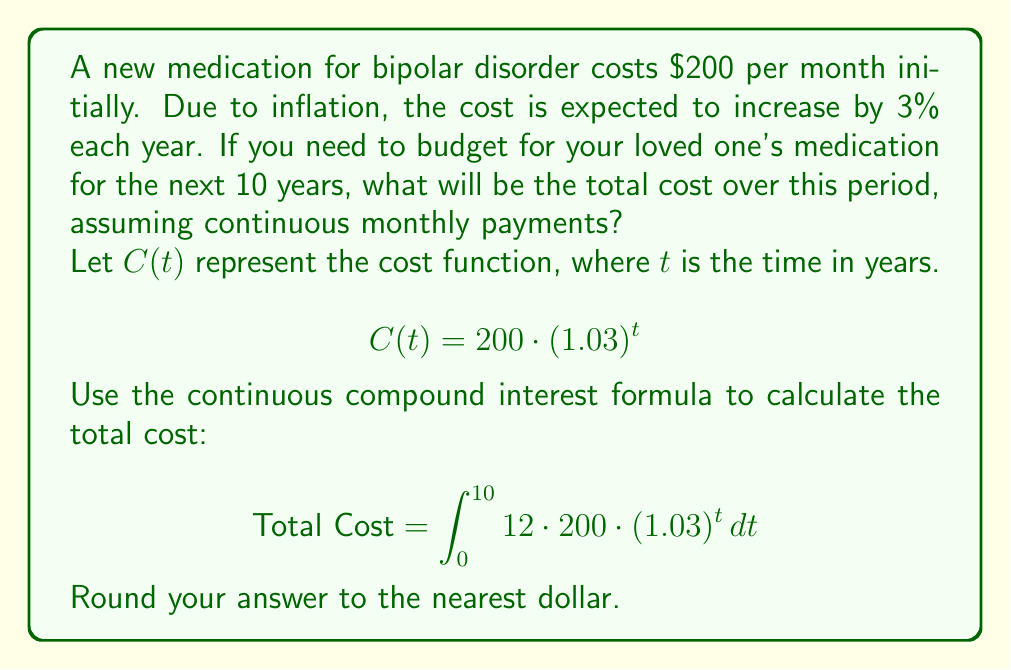Provide a solution to this math problem. To solve this problem, we'll follow these steps:

1) The cost function is given by $C(t) = 200 \cdot (1.03)^t$, where $t$ is in years.

2) To find the total cost over 10 years, we need to integrate this function from 0 to 10, multiplying by 12 to account for monthly payments:

   $$\text{Total Cost} = \int_0^{10} 12 \cdot 200 \cdot (1.03)^t \, dt$$

3) Let's solve this integral:

   $$\begin{align}
   \text{Total Cost} &= 2400 \int_0^{10} (1.03)^t \, dt \\
   &= 2400 \cdot \frac{(1.03)^t}{\ln(1.03)} \bigg|_0^{10} \\
   &= 2400 \cdot \frac{(1.03)^{10} - (1.03)^0}{\ln(1.03)} \\
   &= 2400 \cdot \frac{1.3439 - 1}{0.0296} \\
   &= 2400 \cdot 11.6182 \\
   &= 27,883.68
   \end{align}$$

4) Rounding to the nearest dollar, we get $27,884.

This represents the total cost of the medication over 10 years, taking into account the 3% annual increase in price.
Answer: $27,884 